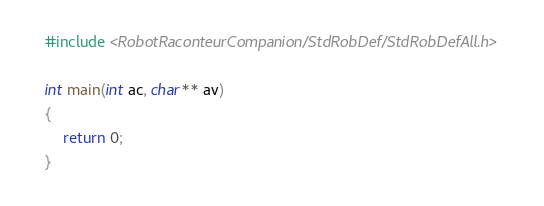<code> <loc_0><loc_0><loc_500><loc_500><_C++_>#include <RobotRaconteurCompanion/StdRobDef/StdRobDefAll.h>

int main(int ac, char** av)
{
	return 0;
}</code> 